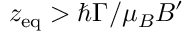<formula> <loc_0><loc_0><loc_500><loc_500>z _ { e q } > \hbar { \Gamma } / \mu _ { B } B ^ { \prime }</formula> 